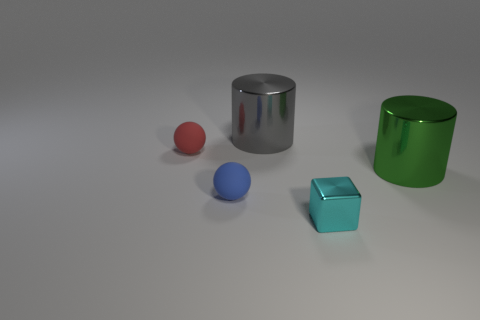Is the number of large gray metal cylinders greater than the number of shiny things?
Make the answer very short. No. Is the size of the blue sphere the same as the red matte thing?
Your answer should be compact. Yes. What number of objects are big gray things or blue matte spheres?
Your response must be concise. 2. There is a small rubber object in front of the cylinder right of the large cylinder that is behind the big green metallic object; what shape is it?
Give a very brief answer. Sphere. Are the ball behind the green shiny cylinder and the large object that is in front of the gray metallic cylinder made of the same material?
Keep it short and to the point. No. What material is the green object that is the same shape as the large gray object?
Offer a very short reply. Metal. Are there any other things that have the same size as the red matte sphere?
Keep it short and to the point. Yes. Is the shape of the large metal object in front of the red matte object the same as the small cyan metallic thing that is on the left side of the green cylinder?
Offer a very short reply. No. Is the number of shiny blocks on the left side of the gray shiny cylinder less than the number of tiny metallic blocks to the left of the cyan thing?
Give a very brief answer. No. What number of other things are there of the same shape as the green shiny object?
Your answer should be very brief. 1. 